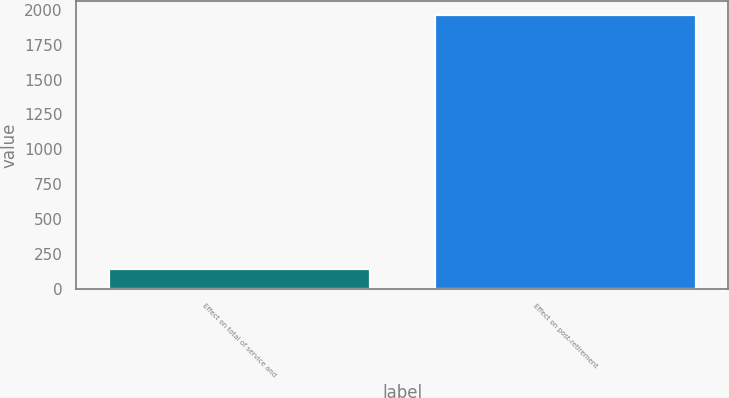Convert chart. <chart><loc_0><loc_0><loc_500><loc_500><bar_chart><fcel>Effect on total of service and<fcel>Effect on post-retirement<nl><fcel>145<fcel>1964<nl></chart> 